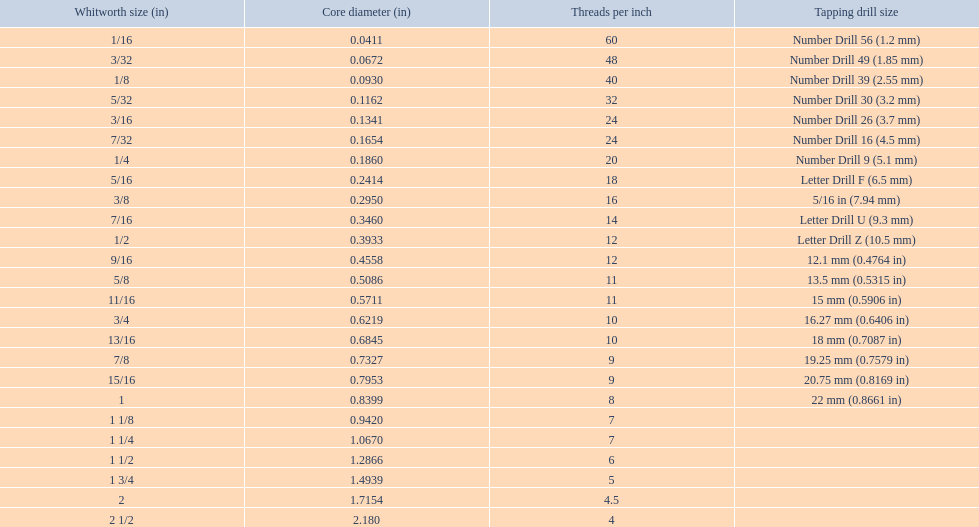What are the whitworth sizes? 1/16, 3/32, 1/8, 5/32, 3/16, 7/32, 1/4, 5/16, 3/8, 7/16, 1/2, 9/16, 5/8, 11/16, 3/4, 13/16, 7/8, 15/16, 1, 1 1/8, 1 1/4, 1 1/2, 1 3/4, 2, 2 1/2. And their threads per inch? 60, 48, 40, 32, 24, 24, 20, 18, 16, 14, 12, 12, 11, 11, 10, 10, 9, 9, 8, 7, 7, 6, 5, 4.5, 4. Now, which whitworth size has a thread-per-inch size of 5?? 1 3/4. 